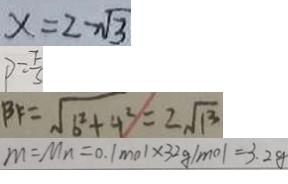<formula> <loc_0><loc_0><loc_500><loc_500>x = 2 - \sqrt { 3 } 
 P = \frac { F } { s } 
 B F = \sqrt { 6 ^ { 2 } + 4 ^ { 2 } } = 2 \sqrt { 1 3 } 
 m = M n = 0 . 1 m o l \times 3 2 g / m o l = 3 . 2 g</formula> 